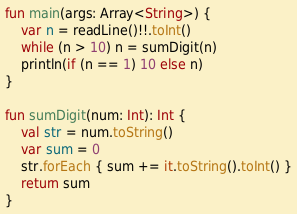Convert code to text. <code><loc_0><loc_0><loc_500><loc_500><_Kotlin_>fun main(args: Array<String>) {
    var n = readLine()!!.toInt()
    while (n > 10) n = sumDigit(n)
    println(if (n == 1) 10 else n)
}

fun sumDigit(num: Int): Int {
    val str = num.toString()
    var sum = 0
    str.forEach { sum += it.toString().toInt() }
    return sum
}</code> 